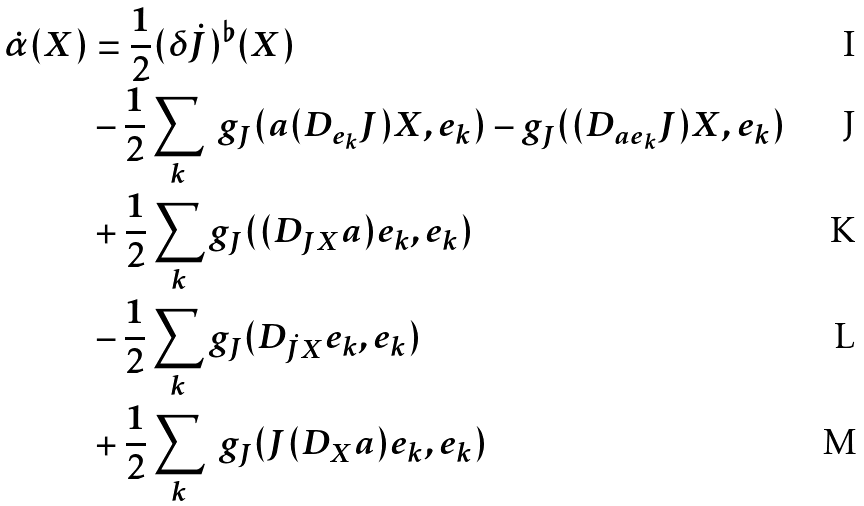<formula> <loc_0><loc_0><loc_500><loc_500>\dot { \alpha } ( X ) & = \frac { 1 } { 2 } ( \delta \dot { J } ) ^ { \flat } ( X ) \\ & - \frac { 1 } { 2 } \sum _ { k } \ g _ { J } ( a ( D _ { e _ { k } } J ) X , e _ { k } ) - g _ { J } ( ( D _ { a e _ { k } } J ) X , e _ { k } ) \\ & + \frac { 1 } { 2 } \sum _ { k } g _ { J } ( ( D _ { J X } a ) e _ { k } , e _ { k } ) \\ & - \frac { 1 } { 2 } \sum _ { k } g _ { J } ( D _ { \dot { J } X } e _ { k } , e _ { k } ) \\ & + \frac { 1 } { 2 } \sum _ { k } \ g _ { J } ( J ( D _ { X } a ) e _ { k } , e _ { k } )</formula> 